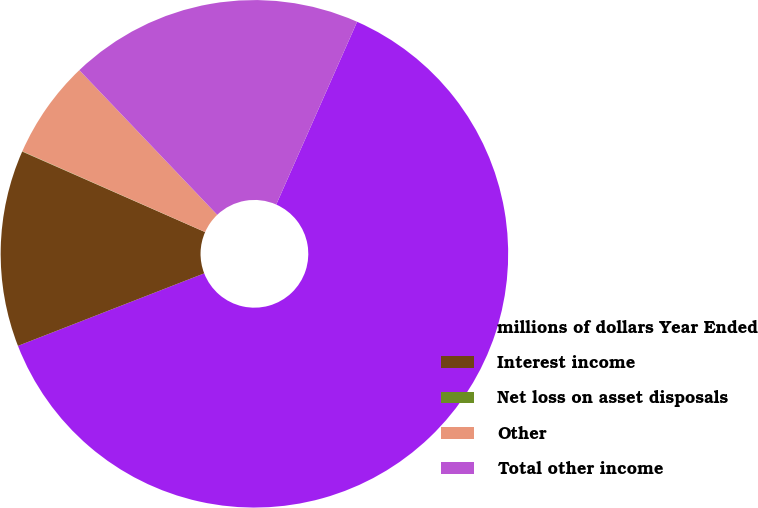Convert chart to OTSL. <chart><loc_0><loc_0><loc_500><loc_500><pie_chart><fcel>millions of dollars Year Ended<fcel>Interest income<fcel>Net loss on asset disposals<fcel>Other<fcel>Total other income<nl><fcel>62.46%<fcel>12.51%<fcel>0.02%<fcel>6.26%<fcel>18.75%<nl></chart> 